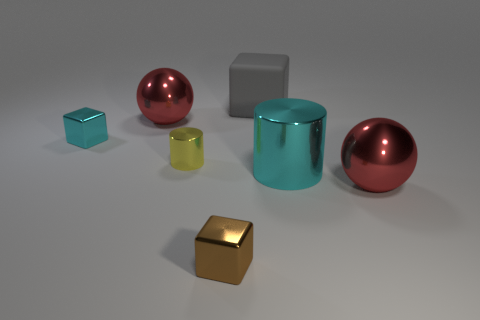There is a object that is the same color as the large cylinder; what is its material?
Ensure brevity in your answer.  Metal. The large thing in front of the metallic cylinder to the right of the gray thing is made of what material?
Your answer should be very brief. Metal. Is the number of large cyan objects that are left of the matte object the same as the number of large red metal spheres that are right of the large cyan object?
Your answer should be compact. No. Is the small yellow metallic object the same shape as the big cyan metal object?
Give a very brief answer. Yes. What is the thing that is both in front of the big cyan object and to the right of the rubber object made of?
Provide a succinct answer. Metal. What number of large red metal objects have the same shape as the big gray object?
Offer a terse response. 0. There is a object that is in front of the red object in front of the cyan metallic thing to the left of the brown shiny thing; what size is it?
Your response must be concise. Small. Is the number of cubes behind the yellow cylinder greater than the number of small brown metal things?
Give a very brief answer. Yes. Are any large cyan matte cylinders visible?
Ensure brevity in your answer.  No. What number of yellow cylinders have the same size as the brown shiny block?
Your response must be concise. 1. 